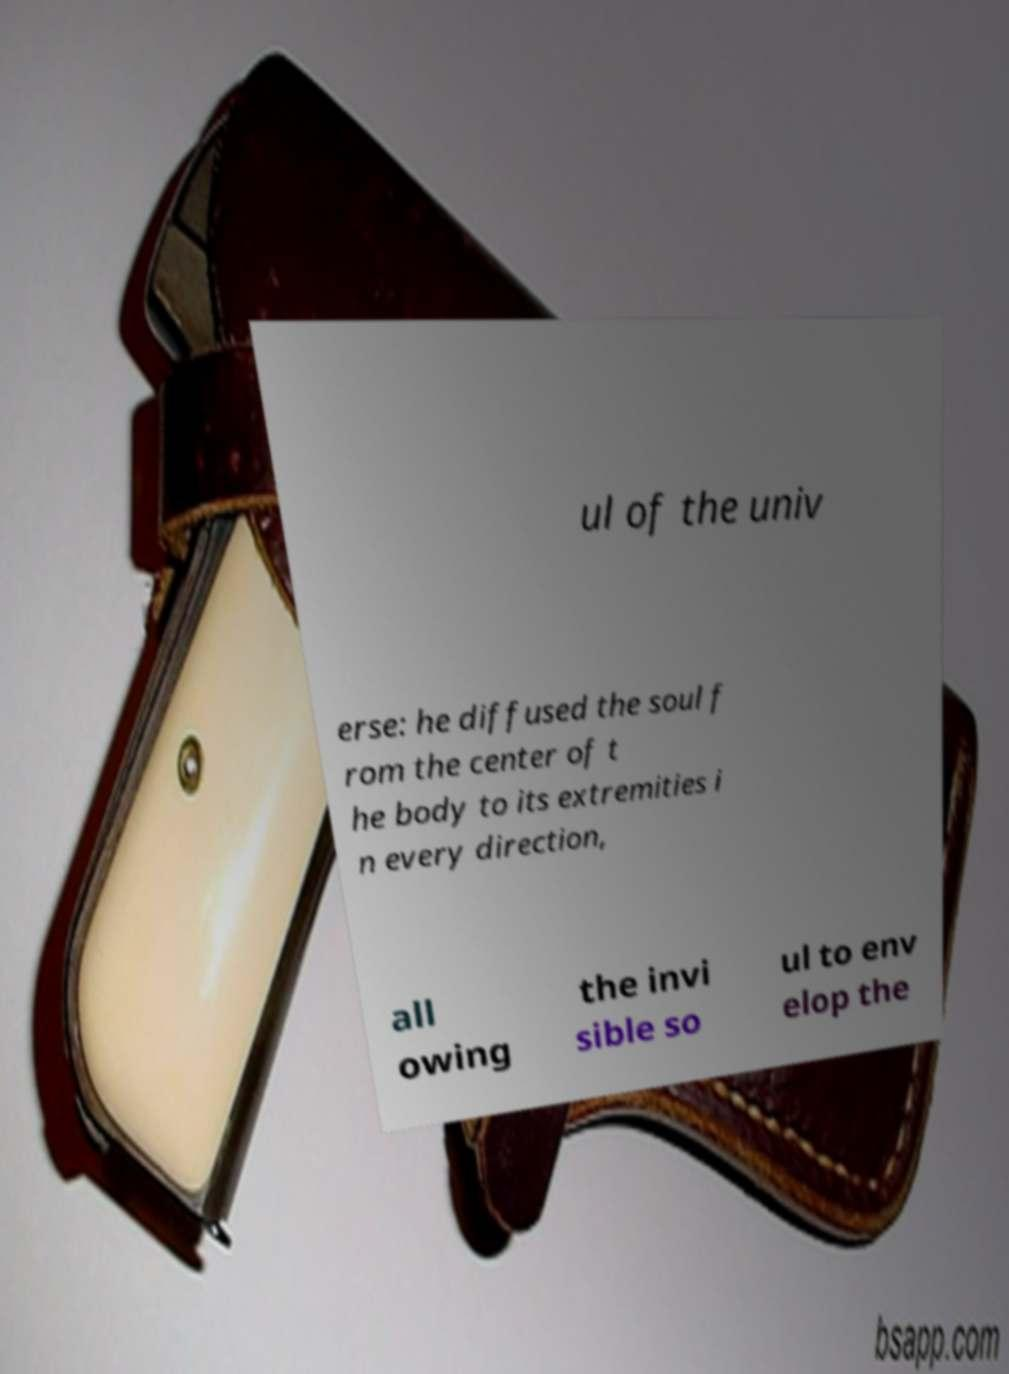Can you accurately transcribe the text from the provided image for me? ul of the univ erse: he diffused the soul f rom the center of t he body to its extremities i n every direction, all owing the invi sible so ul to env elop the 